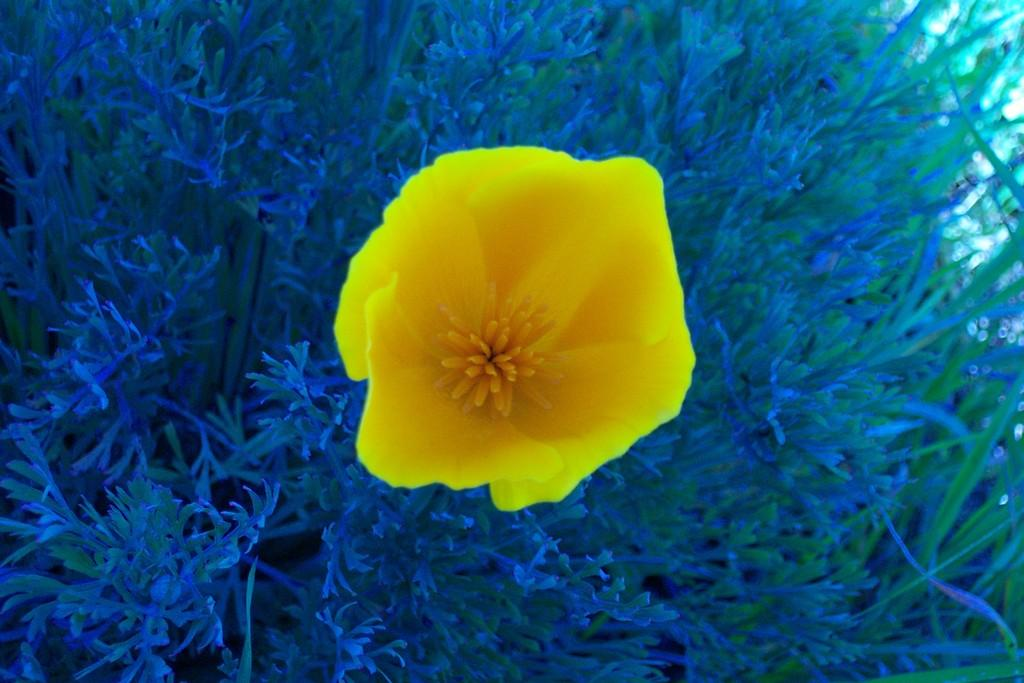What type of living organisms can be seen in the image? Plants can be seen in the image. Can you describe any specific features of the plants? There is a yellow color flower in the image. How many parents are visible in the image? There are no parents present in the image, as it only features plants and a yellow color flower. 